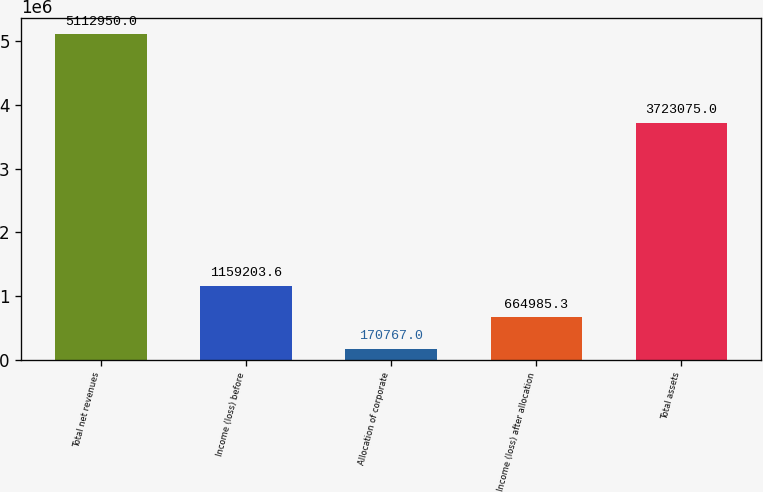Convert chart. <chart><loc_0><loc_0><loc_500><loc_500><bar_chart><fcel>Total net revenues<fcel>Income (loss) before<fcel>Allocation of corporate<fcel>Income (loss) after allocation<fcel>Total assets<nl><fcel>5.11295e+06<fcel>1.1592e+06<fcel>170767<fcel>664985<fcel>3.72308e+06<nl></chart> 